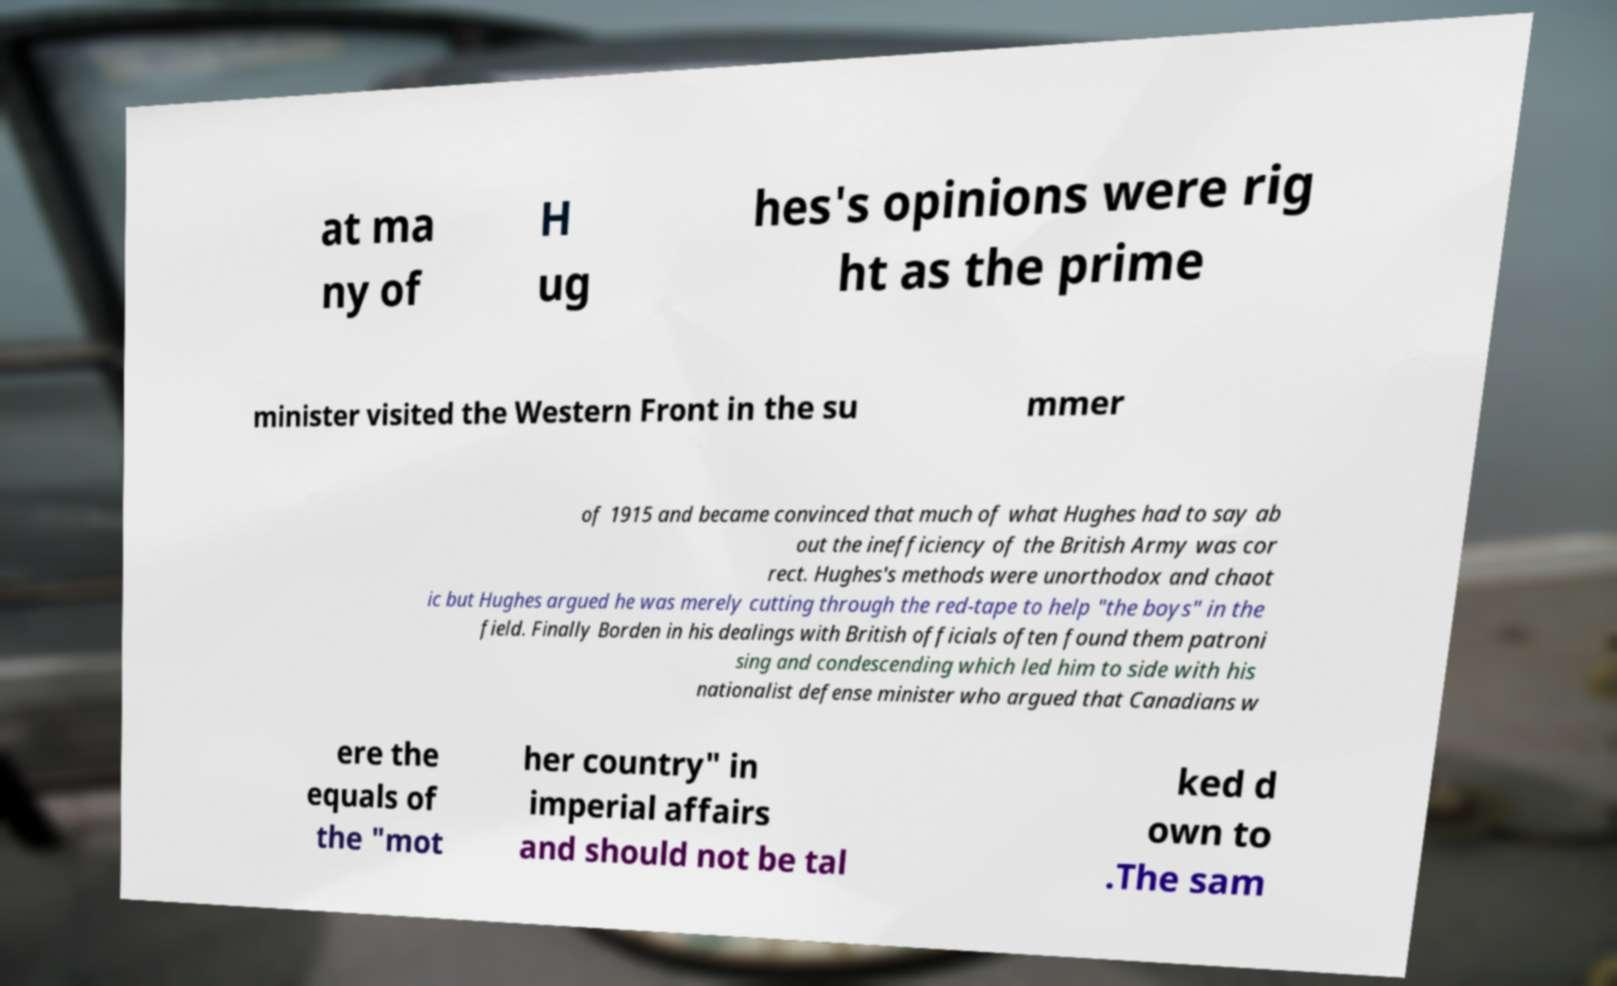For documentation purposes, I need the text within this image transcribed. Could you provide that? at ma ny of H ug hes's opinions were rig ht as the prime minister visited the Western Front in the su mmer of 1915 and became convinced that much of what Hughes had to say ab out the inefficiency of the British Army was cor rect. Hughes's methods were unorthodox and chaot ic but Hughes argued he was merely cutting through the red-tape to help "the boys" in the field. Finally Borden in his dealings with British officials often found them patroni sing and condescending which led him to side with his nationalist defense minister who argued that Canadians w ere the equals of the "mot her country" in imperial affairs and should not be tal ked d own to .The sam 